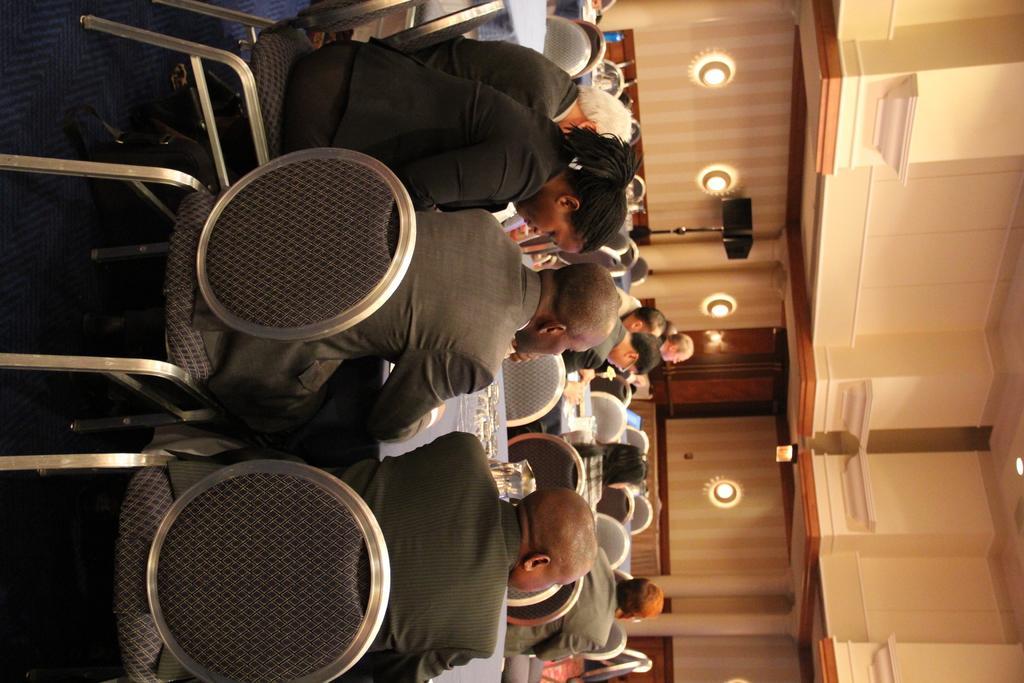In one or two sentences, can you explain what this image depicts? In the image there are a group of people sitting around the different tables and in the background there is a wooden wall and there is some object in front of the wall. 